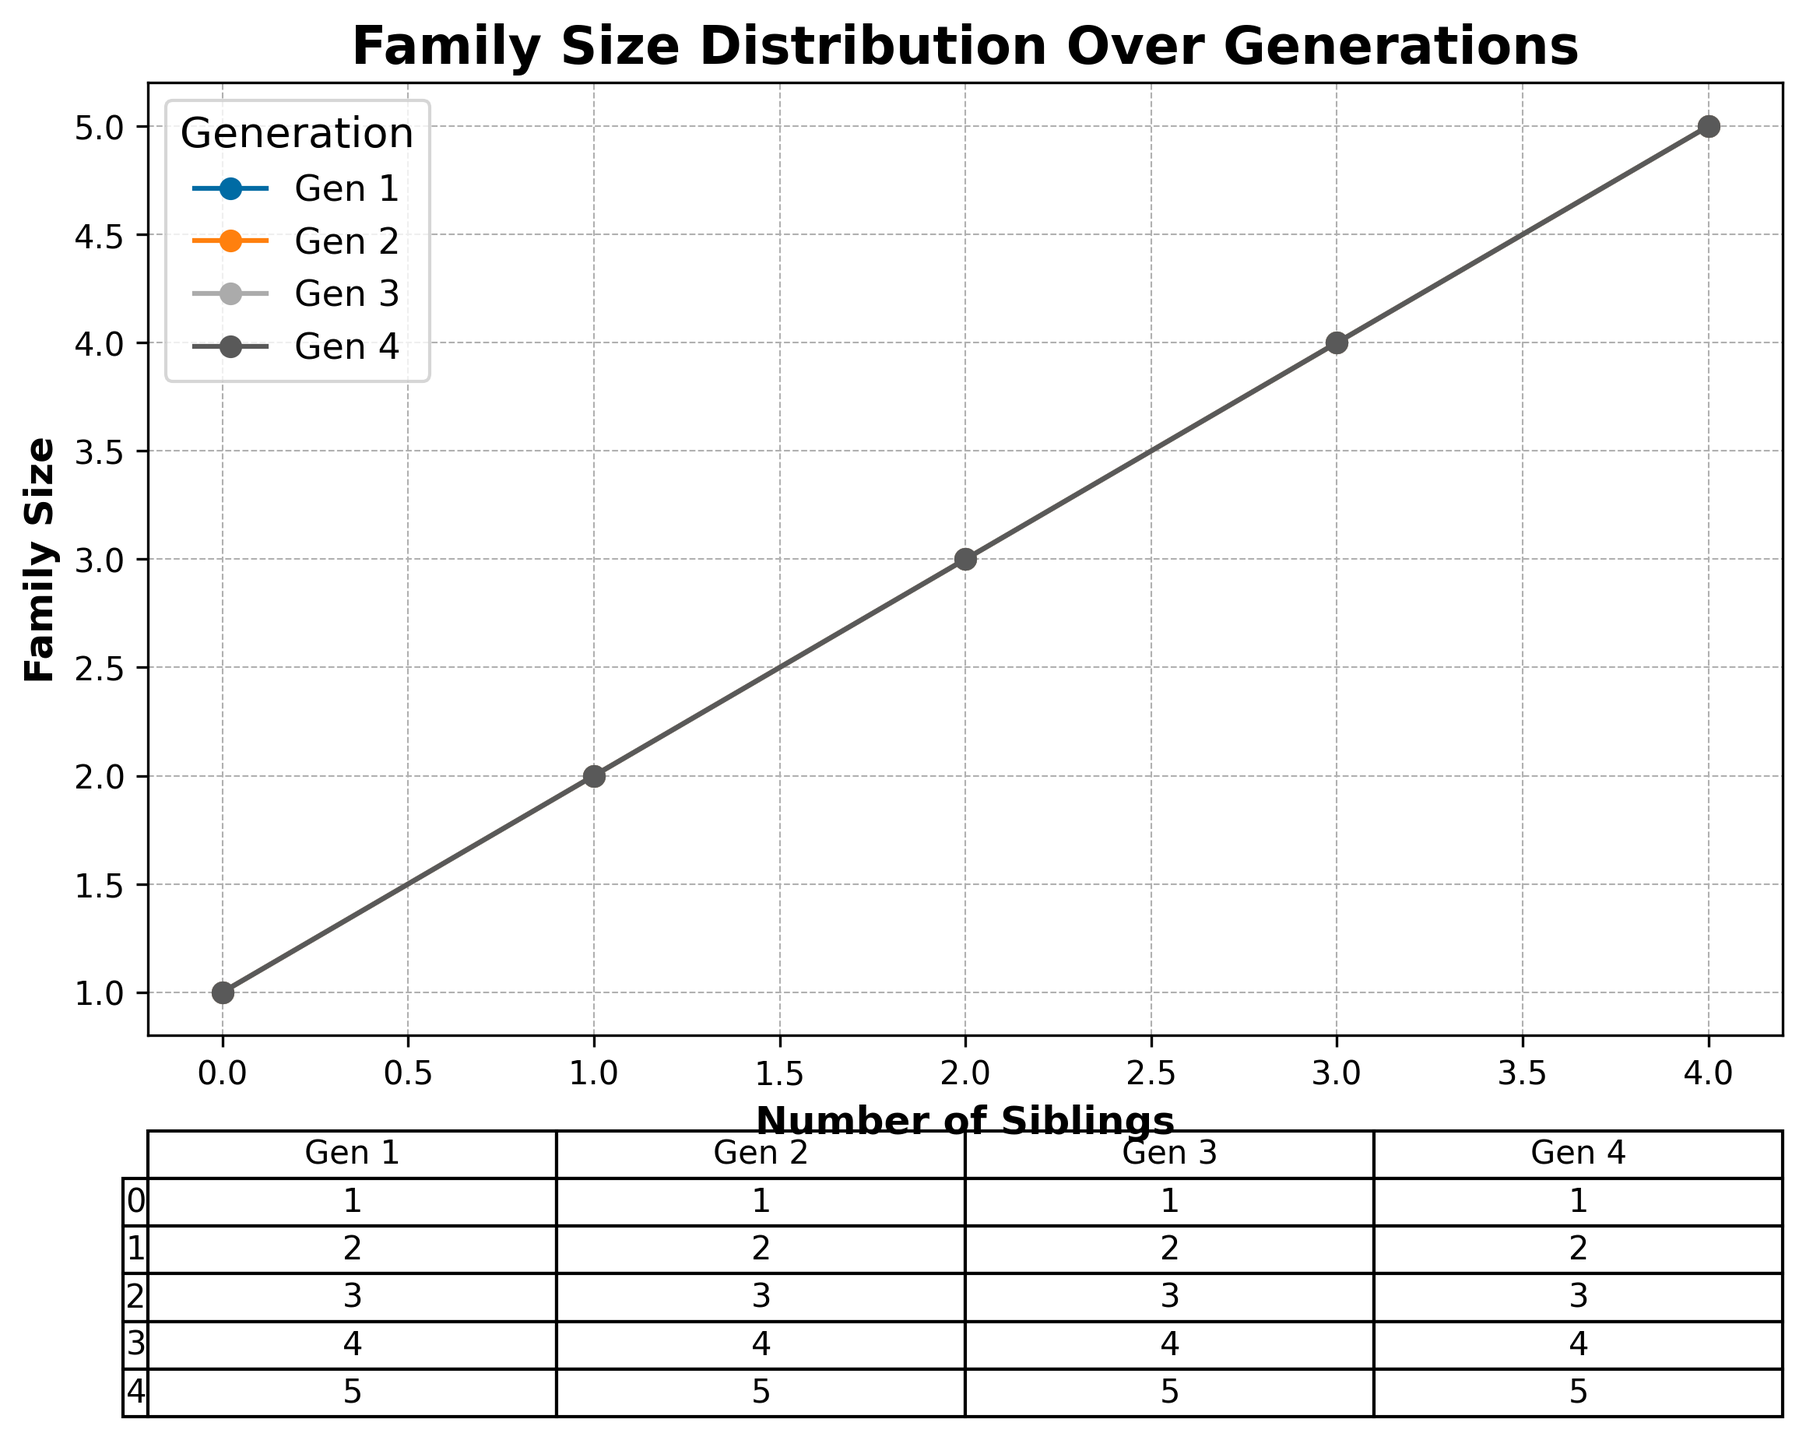What is the title of the chart? The title is located above the chart and is clearly written with a bold font.
Answer: Family Size Distribution Over Generations How many generations are analyzed in the chart? The legend to the right of the chart lists the different generations under analysis.
Answer: Four What is the family size for a sibling count of 3 in Generation 2? For Generation 2, locate the sibling count of 3 on the x-axis and trace upward to the Generation 2 line, marked with a data point.
Answer: 4 What is the largest family size recorded for Generation 1? For Generation 1, the line ends at the sibling count of 4, indicating the highest number of siblings. The corresponding value on the y-axis shows the family size.
Answer: 5 How does the family size trend change from Generation 3 to Generation 4 as the number of siblings increases? Compare the lines for Generations 3 and 4 across the sibling counts on the x-axis, noting whether the points generally go up, go down, or stay the same.
Answer: Remains constant What is the average family size for sibling counts of 0 and 1 across all generations? Locate the family sizes for sibling counts of 0 and 1 in all four generations. Add these values and divide by the number of data points (8 in total). Calculating for each: (1+1+1+1+2+2+2+2)/8 = 12/8
Answer: 1.5 Which generation shows the highest variability in family size as sibling count increases? Observe the line plots of each generation to see which shows the most fluctuation in values along the y-axis as the sibling count increases on the x-axis.
Answer: Generation 1 What is the combined family size for sibling counts of 2 and 3 in Generation 4? Find the family sizes for sibling counts of 2 and 3 in Generation 4 from the chart or table and add them together. Calculating: 3 (sibling count 2) + 4 (sibling count 3)
Answer: 7 Is there any generation where the family size at sibling count 0 differs from 1? If yes, which one? Check the values for sibling counts 0 and 1 for each generation in the chart or table to see if there is a difference.
Answer: No 